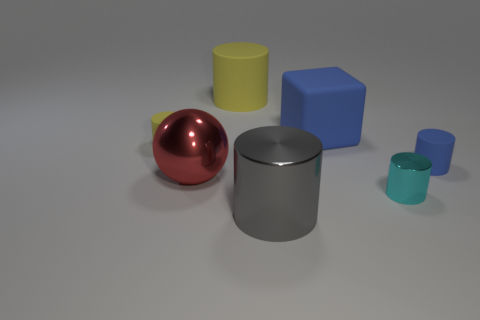What is the large yellow cylinder made of?
Give a very brief answer. Rubber. What number of other objects are there of the same shape as the tiny blue rubber thing?
Make the answer very short. 4. Is the cyan metallic object the same shape as the gray thing?
Offer a very short reply. Yes. What number of things are tiny cylinders that are in front of the red thing or metallic things on the right side of the large blue block?
Offer a very short reply. 1. What number of objects are small metal spheres or blue matte things?
Your answer should be compact. 2. There is a large cylinder that is behind the large blue block; what number of big yellow cylinders are in front of it?
Provide a short and direct response. 0. How many other objects are there of the same size as the gray metallic cylinder?
Give a very brief answer. 3. What size is the other rubber cylinder that is the same color as the large rubber cylinder?
Your answer should be very brief. Small. Does the small rubber object that is on the left side of the large gray metal cylinder have the same shape as the tiny cyan metal object?
Keep it short and to the point. Yes. What is the yellow cylinder that is on the right side of the small yellow matte thing made of?
Make the answer very short. Rubber. 